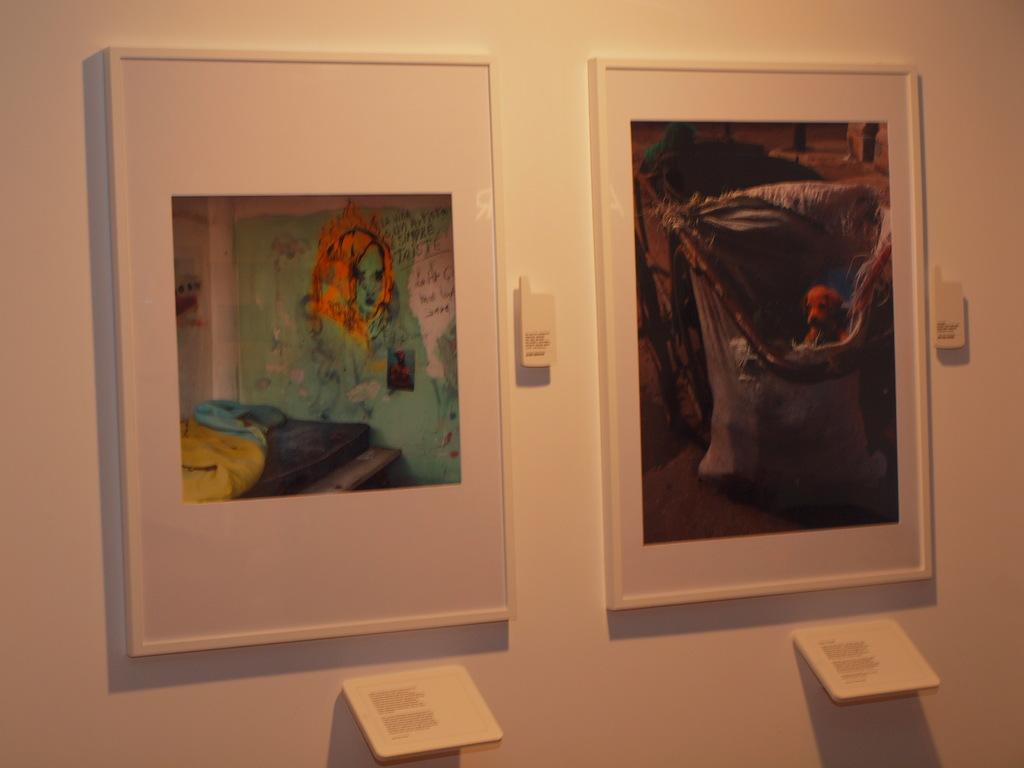What is hanging on the white wall in the image? There are two photo frames on the white wall. Can you describe any other objects visible in the image? Yes, there are small boards visible in the image. What reward is being given to the brothers in the image? There are no brothers or rewards present in the image; it only features photo frames and small boards. What caption is written on the photo frames in the image? There is no caption visible on the photo frames in the image; only the images themselves can be seen. 